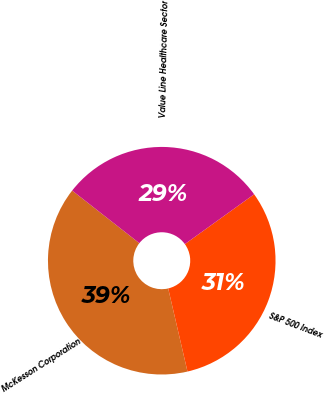Convert chart to OTSL. <chart><loc_0><loc_0><loc_500><loc_500><pie_chart><fcel>McKesson Corporation<fcel>S&P 500 Index<fcel>Value Line Healthcare Sector<nl><fcel>39.21%<fcel>31.29%<fcel>29.5%<nl></chart> 